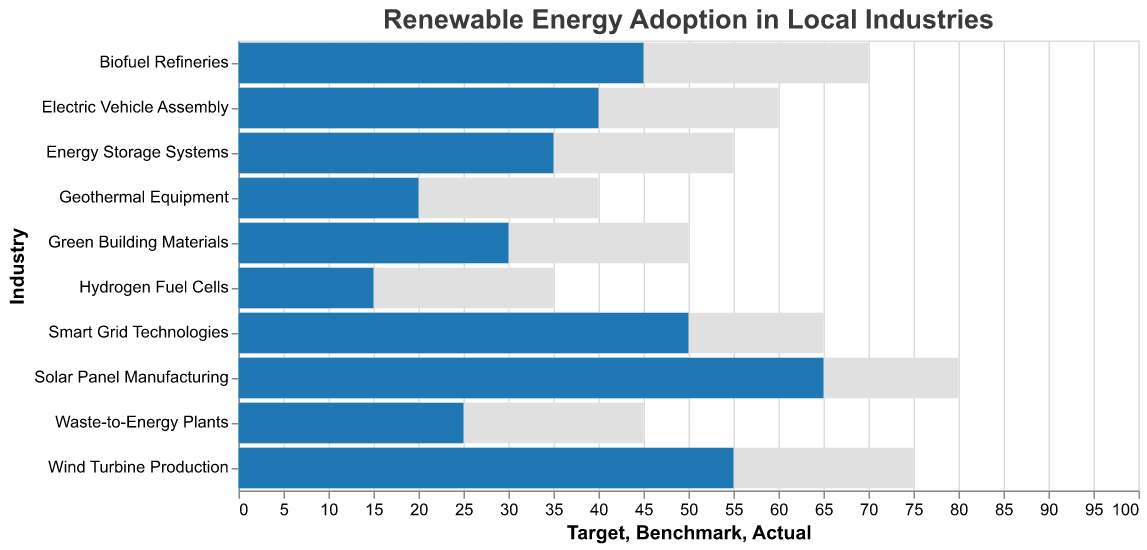What is the title of the chart? The title of the chart is usually displayed at the top of the figure and indicates what the chart represents. In this case, the title is "Renewable Energy Adoption in Local Industries" as it is directly stated in the code.
Answer: Renewable Energy Adoption in Local Industries Which industry has the highest actual percentage of renewable energy adoption? To find the industry with the highest actual percentage of renewable energy adoption, one needs to look at the maximum value in the "Actual" field among all industries. "Solar Panel Manufacturing" has the highest value of 65%.
Answer: Solar Panel Manufacturing What is the benchmark percentage for Wind Turbine Production? The benchmark percentage for each industry is indicated by the "Benchmark" value in the data. For Wind Turbine Production, the benchmark percentage is 45%.
Answer: 45% How many industries have an actual percentage that surpasses their benchmarks? To answer this, you compare the "Actual" values with the "Benchmark" values for each industry. If the "Actual" value is greater than the "Benchmark" value, it surpasses the benchmark. For this dataset: Solar Panel Manufacturing, Wind Turbine Production, Electric Vehicle Assembly, Biofuel Refineries, Smart Grid Technologies, and Energy Storage Systems surpass their benchmarks.
Answer: 6 industries What is the average target percentage for the renewable energy adoption across all industries? To calculate the average target percentage, sum up all the target percentages and divide by the number of industries. These values are 80, 75, 60, 50, 70, 55, 65, 45, 40, and 35. Sum these values to get 575 and divide by the number of industries, which is 10. So, 575/10 = 57.5.
Answer: 57.5% Which industry has the largest gap between its target and actual adoption percentages? To find the largest gap, calculate the differences between the target and actual percentages for each industry and find the largest one. The differences are: 15 (Solar), 20 (Wind), 20 (Vehicle), 20 (Building), 25 (Biofuel), 20 (Energy Storage), 15 (Smart Grid), 20 (Waste-to-Energy), 20 (Geothermal), 20 (Hydrogen Fuel). The largest gap is 25 for Biofuel Refineries.
Answer: Biofuel Refineries What is the total sum of actual percentages across all industries? Sum the actual percentages of renewable energy adoption for all industries. These values are 65, 55, 40, 30, 45, 35, 50, 25, 20, and 15. Sum these values to get 380.
Answer: 380 Which industry is furthest from its benchmark and by how much? Calculate the absolute differences between the actual and benchmark percentages for each industry. The differences are: 15 (Solar), 10 (Wind), 5 (Vehicle), 5 (Building), 5 (Biofuel), 5 (Energy), 10 (Smart Grid), 5 (Waste), 5 (Geothermal), 5 (Hydrogen). The furthest industry from its benchmark is Solar Panel Manufacturing with a difference of 15.
Answer: Solar Panel Manufacturing, 15% What color represents the actual percentage values in the chart? According to the code, the color representing the actual percentages in the chart is specified as "#1f77b4", which is a shade of blue.
Answer: Blue 